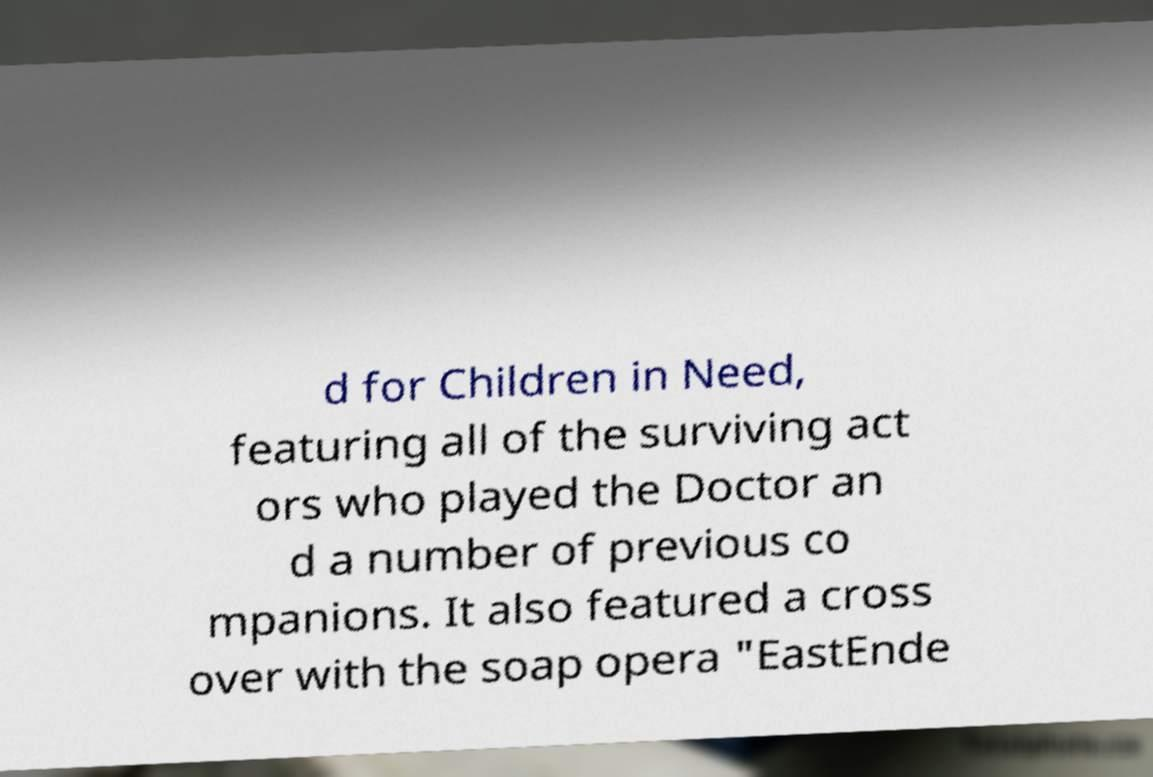Can you accurately transcribe the text from the provided image for me? d for Children in Need, featuring all of the surviving act ors who played the Doctor an d a number of previous co mpanions. It also featured a cross over with the soap opera "EastEnde 